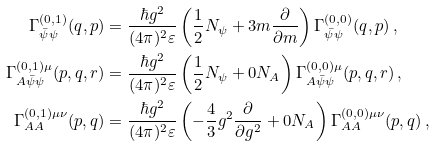Convert formula to latex. <formula><loc_0><loc_0><loc_500><loc_500>\Gamma ^ { ( 0 , 1 ) } _ { \bar { \psi } \psi } ( q , p ) & = \frac { \hbar { g } ^ { 2 } } { ( 4 \pi ) ^ { 2 } \varepsilon } \left ( \frac { 1 } { 2 } N _ { \psi } + 3 m \frac { \partial } { \partial m } \right ) \Gamma ^ { ( 0 , 0 ) } _ { \bar { \psi } \psi } ( q , p ) \, , \\ \Gamma ^ { ( 0 , 1 ) \mu } _ { A \bar { \psi } \psi } ( p , q , r ) & = \frac { \hbar { g } ^ { 2 } } { ( 4 \pi ) ^ { 2 } \varepsilon } \left ( \frac { 1 } { 2 } N _ { \psi } + 0 N _ { A } \right ) \Gamma ^ { ( 0 , 0 ) \mu } _ { A \bar { \psi } \psi } ( p , q , r ) \, , \\ \Gamma ^ { ( 0 , 1 ) \mu \nu } _ { A A } ( p , q ) & = \frac { \hbar { g } ^ { 2 } } { ( 4 \pi ) ^ { 2 } \varepsilon } \left ( - \frac { 4 } { 3 } g ^ { 2 } \frac { \partial } { \partial g ^ { 2 } } + 0 N _ { A } \right ) \Gamma ^ { ( 0 , 0 ) \mu \nu } _ { A A } ( p , q ) \, ,</formula> 